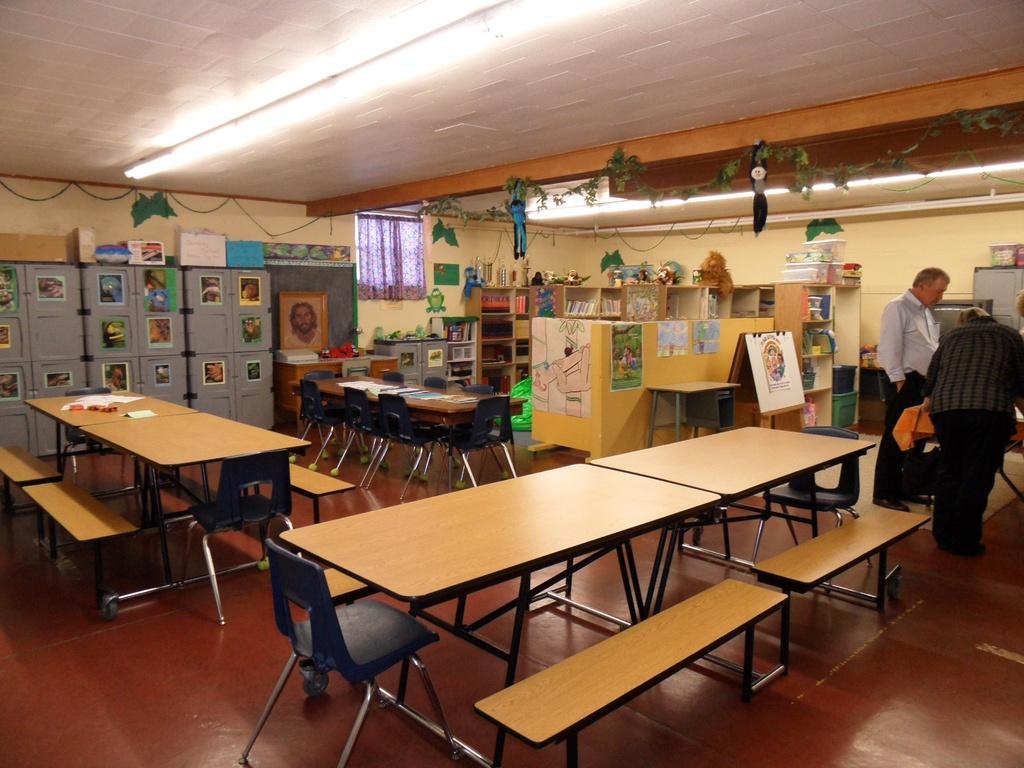Describe this image in one or two sentences. There are two people standing in the right corner and there are tables and benches which are left empty. 